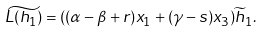<formula> <loc_0><loc_0><loc_500><loc_500>\widetilde { L ( h _ { 1 } ) } = ( ( \alpha - \beta + r ) x _ { 1 } + ( \gamma - s ) x _ { 3 } ) \widetilde { h } _ { 1 } .</formula> 